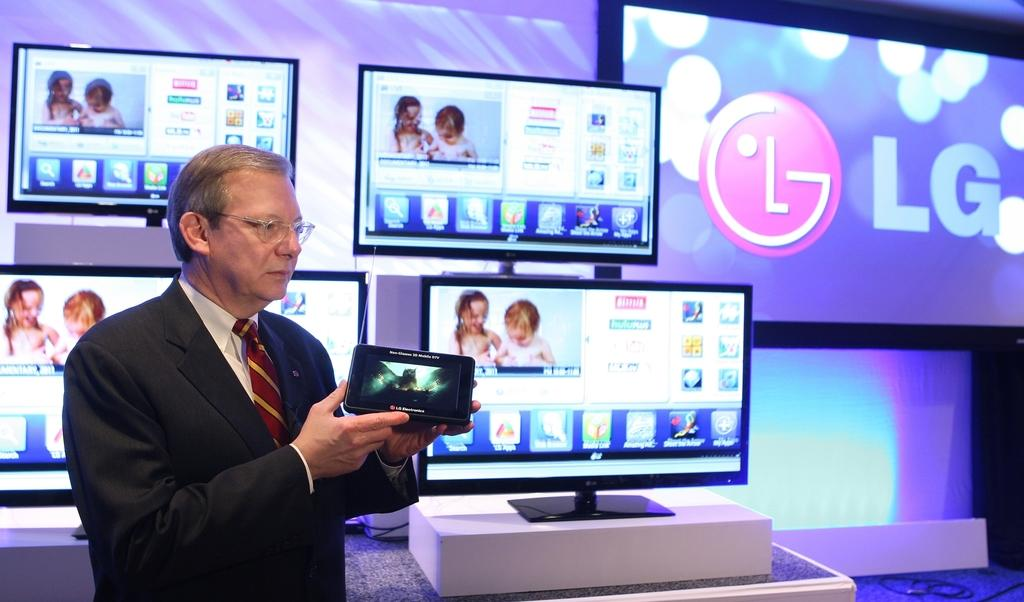<image>
Offer a succinct explanation of the picture presented. A man standing in front of several LG branded screens while holding a phone. 